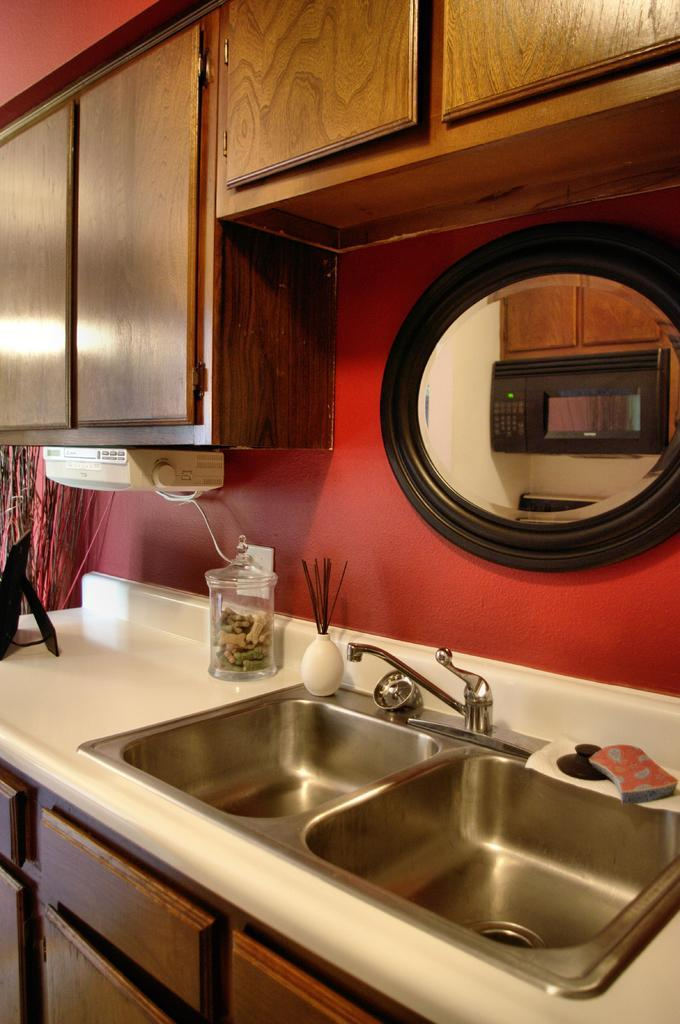What type of plumbing fixture is visible in the image? There is a tap in the image. What are the sinks used for? The sinks are likely used for washing hands or other cleaning purposes. What color is the surface on which other objects are placed? The surface is white. What material is used for some of the objects in the image? Wooden objects are present in the image. How many children are playing with the trick in the image? There is no trick or children present in the image. 